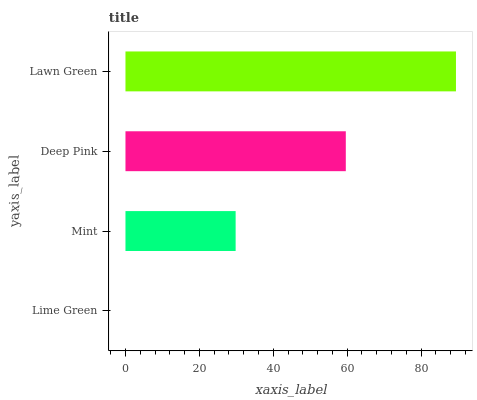Is Lime Green the minimum?
Answer yes or no. Yes. Is Lawn Green the maximum?
Answer yes or no. Yes. Is Mint the minimum?
Answer yes or no. No. Is Mint the maximum?
Answer yes or no. No. Is Mint greater than Lime Green?
Answer yes or no. Yes. Is Lime Green less than Mint?
Answer yes or no. Yes. Is Lime Green greater than Mint?
Answer yes or no. No. Is Mint less than Lime Green?
Answer yes or no. No. Is Deep Pink the high median?
Answer yes or no. Yes. Is Mint the low median?
Answer yes or no. Yes. Is Mint the high median?
Answer yes or no. No. Is Deep Pink the low median?
Answer yes or no. No. 